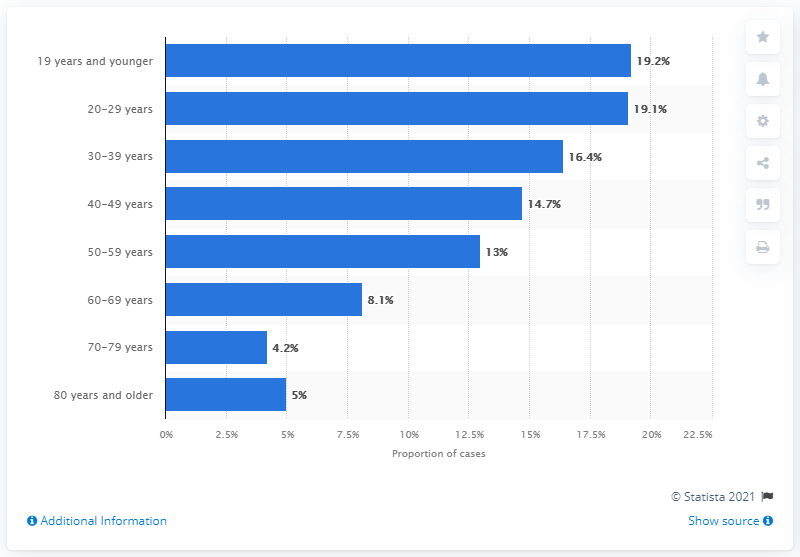Indicate a few pertinent items in this graphic. According to data as of June 25, 2021, a total of 19.2% of COVID-19 cases in Canada were under the age of 19. 